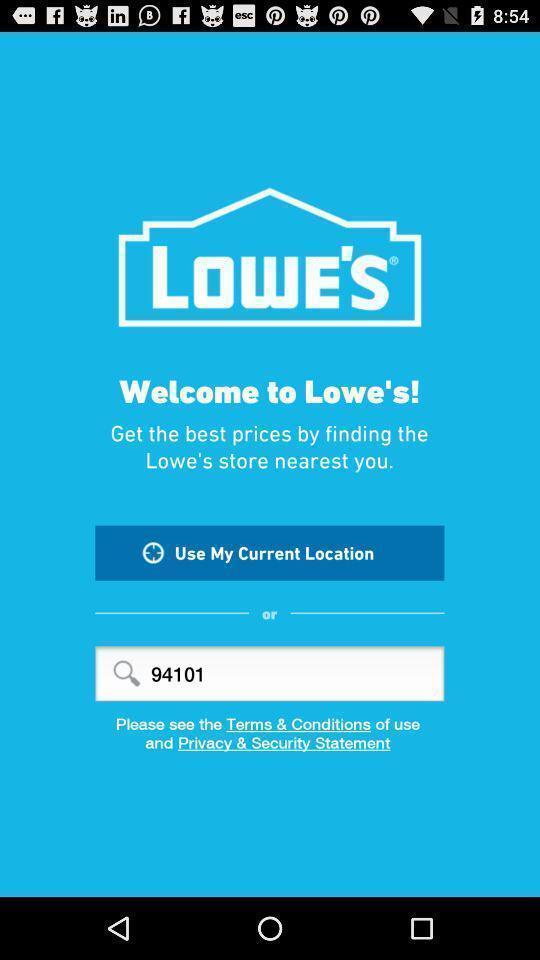Describe the visual elements of this screenshot. Welcome page of finding nearest store application. 